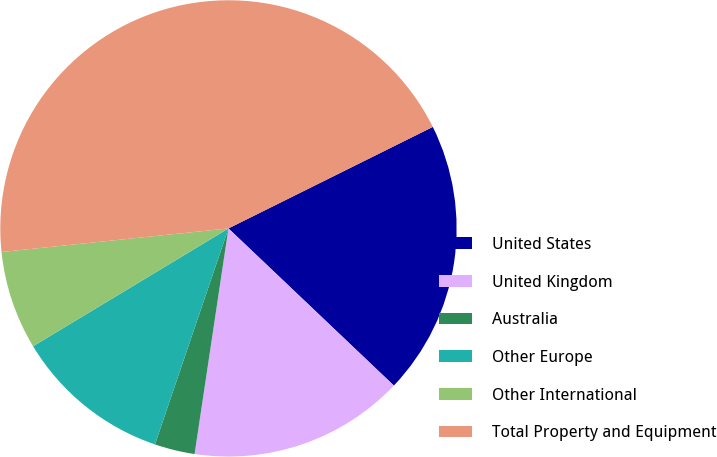Convert chart. <chart><loc_0><loc_0><loc_500><loc_500><pie_chart><fcel>United States<fcel>United Kingdom<fcel>Australia<fcel>Other Europe<fcel>Other International<fcel>Total Property and Equipment<nl><fcel>19.43%<fcel>15.28%<fcel>2.85%<fcel>11.14%<fcel>6.99%<fcel>44.31%<nl></chart> 